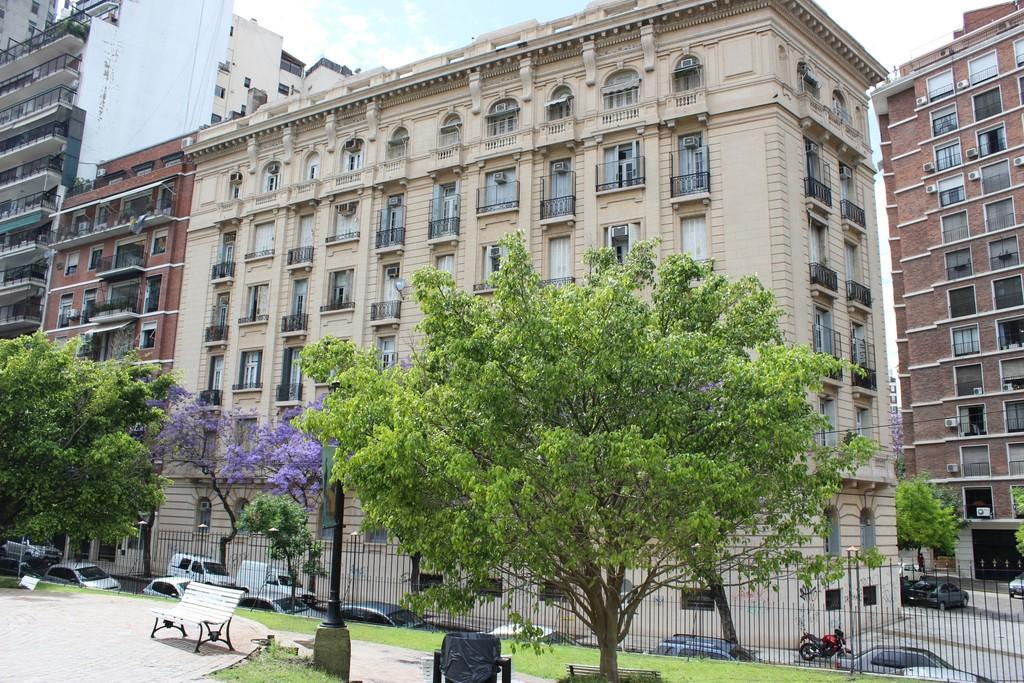In one or two sentences, can you explain what this image depicts? In this picture in the front there is a pole, there are cars, there is a tree and there is grass on the ground. In the background there are buildings, in front of the buildings there are cars on the road and the sky is cloudy. 